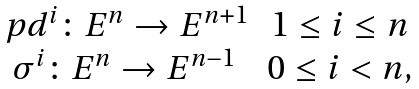Convert formula to latex. <formula><loc_0><loc_0><loc_500><loc_500>\begin{matrix} \ p d ^ { i } \colon E ^ { n } \to E ^ { n + 1 } & 1 \leq i \leq n \\ \sigma ^ { i } \colon E ^ { n } \to E ^ { n - 1 } & 0 \leq i < n , \end{matrix}</formula> 